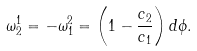<formula> <loc_0><loc_0><loc_500><loc_500>\omega ^ { 1 } _ { 2 } = - \omega ^ { 2 } _ { 1 } = \left ( 1 - \frac { c _ { 2 } } { c _ { 1 } } \right ) d \phi .</formula> 